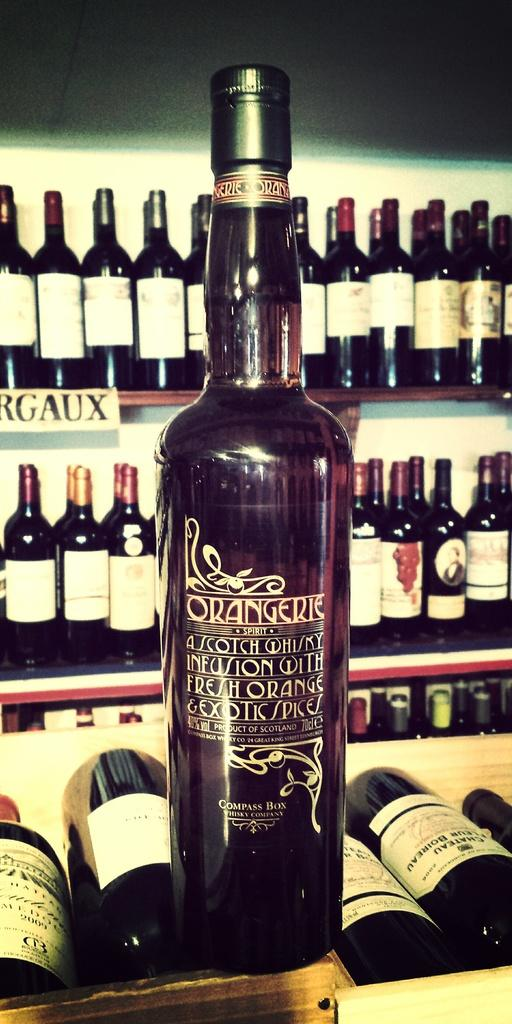<image>
Render a clear and concise summary of the photo. Bottles of foreign made alcohol are out on display. 